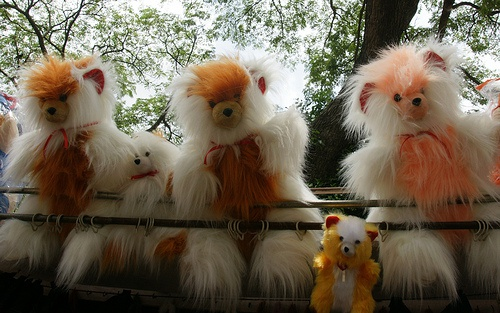Describe the objects in this image and their specific colors. I can see teddy bear in lightgray, gray, maroon, and darkgray tones, teddy bear in lightgray, black, gray, and maroon tones, teddy bear in lightgray, black, gray, and maroon tones, teddy bear in lightgray, maroon, olive, and black tones, and teddy bear in lightgray, gray, darkgray, and maroon tones in this image. 